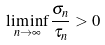<formula> <loc_0><loc_0><loc_500><loc_500>\liminf _ { n \to \infty } \frac { \sigma _ { n } } { \tau _ { n } } > 0</formula> 